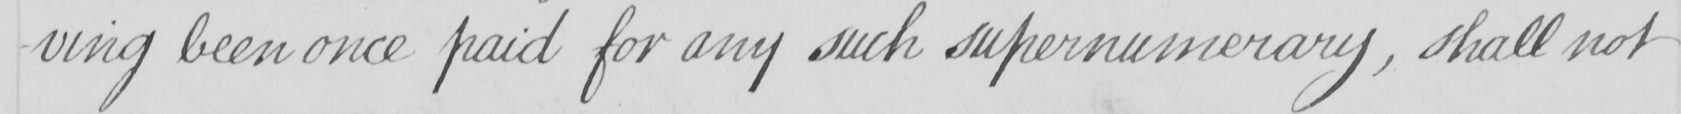Please provide the text content of this handwritten line. -ving been once paid for any such supernumerary , shall not 